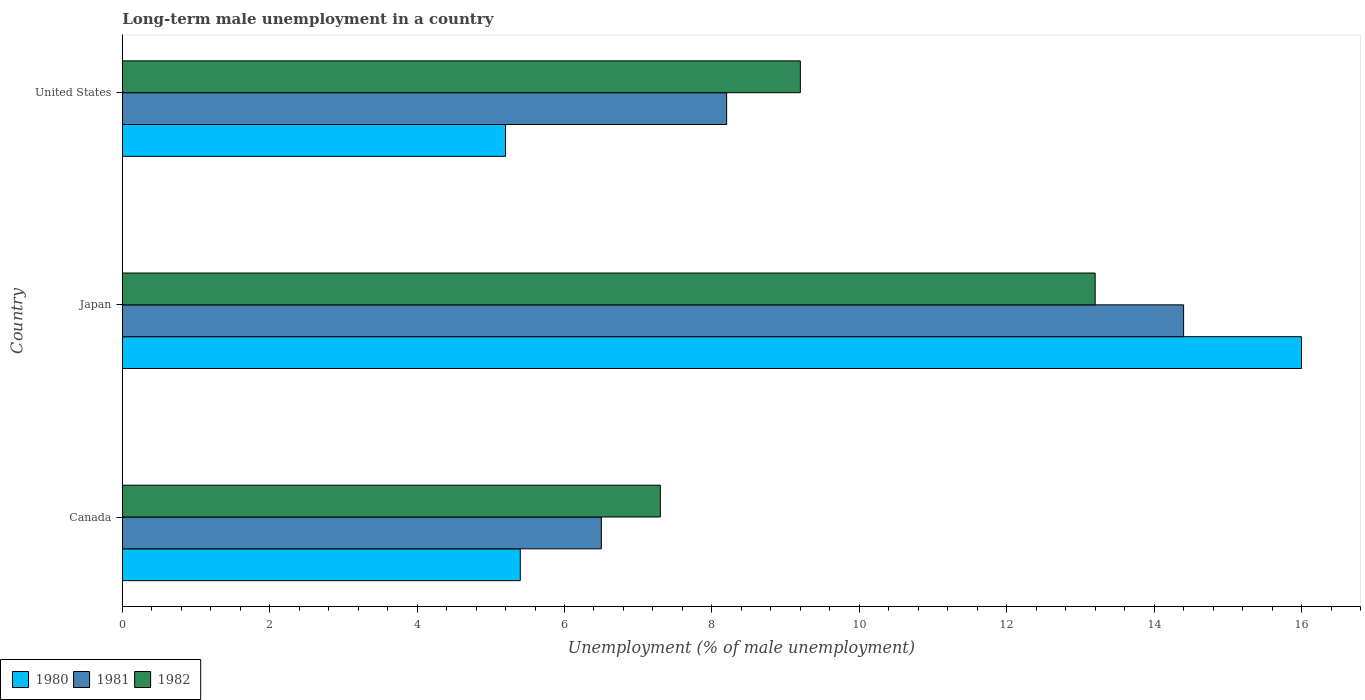How many different coloured bars are there?
Make the answer very short. 3. Are the number of bars per tick equal to the number of legend labels?
Give a very brief answer. Yes. Are the number of bars on each tick of the Y-axis equal?
Give a very brief answer. Yes. How many bars are there on the 1st tick from the top?
Make the answer very short. 3. What is the label of the 3rd group of bars from the top?
Keep it short and to the point. Canada. In how many cases, is the number of bars for a given country not equal to the number of legend labels?
Ensure brevity in your answer.  0. What is the percentage of long-term unemployed male population in 1982 in Canada?
Give a very brief answer. 7.3. Across all countries, what is the maximum percentage of long-term unemployed male population in 1982?
Keep it short and to the point. 13.2. Across all countries, what is the minimum percentage of long-term unemployed male population in 1982?
Offer a very short reply. 7.3. In which country was the percentage of long-term unemployed male population in 1981 maximum?
Make the answer very short. Japan. What is the total percentage of long-term unemployed male population in 1980 in the graph?
Offer a terse response. 26.6. What is the difference between the percentage of long-term unemployed male population in 1980 in Japan and that in United States?
Your answer should be very brief. 10.8. What is the difference between the percentage of long-term unemployed male population in 1981 in Canada and the percentage of long-term unemployed male population in 1980 in United States?
Offer a terse response. 1.3. What is the average percentage of long-term unemployed male population in 1982 per country?
Your answer should be compact. 9.9. What is the difference between the percentage of long-term unemployed male population in 1982 and percentage of long-term unemployed male population in 1980 in Japan?
Keep it short and to the point. -2.8. In how many countries, is the percentage of long-term unemployed male population in 1980 greater than 0.4 %?
Your answer should be compact. 3. What is the ratio of the percentage of long-term unemployed male population in 1982 in Japan to that in United States?
Give a very brief answer. 1.43. Is the percentage of long-term unemployed male population in 1980 in Canada less than that in Japan?
Give a very brief answer. Yes. Is the difference between the percentage of long-term unemployed male population in 1982 in Canada and United States greater than the difference between the percentage of long-term unemployed male population in 1980 in Canada and United States?
Provide a succinct answer. No. What is the difference between the highest and the second highest percentage of long-term unemployed male population in 1982?
Keep it short and to the point. 4. What is the difference between the highest and the lowest percentage of long-term unemployed male population in 1982?
Offer a very short reply. 5.9. In how many countries, is the percentage of long-term unemployed male population in 1981 greater than the average percentage of long-term unemployed male population in 1981 taken over all countries?
Offer a terse response. 1. Is the sum of the percentage of long-term unemployed male population in 1981 in Canada and United States greater than the maximum percentage of long-term unemployed male population in 1980 across all countries?
Give a very brief answer. No. What does the 1st bar from the bottom in United States represents?
Make the answer very short. 1980. How many bars are there?
Offer a very short reply. 9. What is the difference between two consecutive major ticks on the X-axis?
Your answer should be compact. 2. Are the values on the major ticks of X-axis written in scientific E-notation?
Make the answer very short. No. What is the title of the graph?
Provide a succinct answer. Long-term male unemployment in a country. What is the label or title of the X-axis?
Your response must be concise. Unemployment (% of male unemployment). What is the label or title of the Y-axis?
Give a very brief answer. Country. What is the Unemployment (% of male unemployment) in 1980 in Canada?
Your answer should be very brief. 5.4. What is the Unemployment (% of male unemployment) of 1981 in Canada?
Your answer should be compact. 6.5. What is the Unemployment (% of male unemployment) of 1982 in Canada?
Offer a terse response. 7.3. What is the Unemployment (% of male unemployment) of 1980 in Japan?
Your answer should be very brief. 16. What is the Unemployment (% of male unemployment) in 1981 in Japan?
Your response must be concise. 14.4. What is the Unemployment (% of male unemployment) in 1982 in Japan?
Ensure brevity in your answer.  13.2. What is the Unemployment (% of male unemployment) of 1980 in United States?
Keep it short and to the point. 5.2. What is the Unemployment (% of male unemployment) in 1981 in United States?
Your answer should be very brief. 8.2. What is the Unemployment (% of male unemployment) in 1982 in United States?
Offer a very short reply. 9.2. Across all countries, what is the maximum Unemployment (% of male unemployment) in 1980?
Give a very brief answer. 16. Across all countries, what is the maximum Unemployment (% of male unemployment) in 1981?
Give a very brief answer. 14.4. Across all countries, what is the maximum Unemployment (% of male unemployment) of 1982?
Offer a very short reply. 13.2. Across all countries, what is the minimum Unemployment (% of male unemployment) in 1980?
Make the answer very short. 5.2. Across all countries, what is the minimum Unemployment (% of male unemployment) in 1981?
Give a very brief answer. 6.5. Across all countries, what is the minimum Unemployment (% of male unemployment) in 1982?
Give a very brief answer. 7.3. What is the total Unemployment (% of male unemployment) in 1980 in the graph?
Make the answer very short. 26.6. What is the total Unemployment (% of male unemployment) in 1981 in the graph?
Offer a very short reply. 29.1. What is the total Unemployment (% of male unemployment) of 1982 in the graph?
Offer a terse response. 29.7. What is the difference between the Unemployment (% of male unemployment) of 1980 in Canada and that in Japan?
Your response must be concise. -10.6. What is the difference between the Unemployment (% of male unemployment) in 1982 in Canada and that in Japan?
Your response must be concise. -5.9. What is the difference between the Unemployment (% of male unemployment) of 1980 in Japan and that in United States?
Keep it short and to the point. 10.8. What is the difference between the Unemployment (% of male unemployment) of 1981 in Japan and that in United States?
Keep it short and to the point. 6.2. What is the difference between the Unemployment (% of male unemployment) of 1980 in Canada and the Unemployment (% of male unemployment) of 1982 in Japan?
Offer a very short reply. -7.8. What is the difference between the Unemployment (% of male unemployment) in 1981 in Canada and the Unemployment (% of male unemployment) in 1982 in Japan?
Offer a terse response. -6.7. What is the difference between the Unemployment (% of male unemployment) in 1980 in Japan and the Unemployment (% of male unemployment) in 1982 in United States?
Ensure brevity in your answer.  6.8. What is the difference between the Unemployment (% of male unemployment) of 1981 in Japan and the Unemployment (% of male unemployment) of 1982 in United States?
Offer a very short reply. 5.2. What is the average Unemployment (% of male unemployment) of 1980 per country?
Make the answer very short. 8.87. What is the difference between the Unemployment (% of male unemployment) of 1981 and Unemployment (% of male unemployment) of 1982 in Japan?
Provide a succinct answer. 1.2. What is the difference between the Unemployment (% of male unemployment) of 1980 and Unemployment (% of male unemployment) of 1982 in United States?
Make the answer very short. -4. What is the ratio of the Unemployment (% of male unemployment) of 1980 in Canada to that in Japan?
Keep it short and to the point. 0.34. What is the ratio of the Unemployment (% of male unemployment) of 1981 in Canada to that in Japan?
Provide a succinct answer. 0.45. What is the ratio of the Unemployment (% of male unemployment) in 1982 in Canada to that in Japan?
Your answer should be very brief. 0.55. What is the ratio of the Unemployment (% of male unemployment) of 1980 in Canada to that in United States?
Provide a short and direct response. 1.04. What is the ratio of the Unemployment (% of male unemployment) of 1981 in Canada to that in United States?
Provide a short and direct response. 0.79. What is the ratio of the Unemployment (% of male unemployment) of 1982 in Canada to that in United States?
Provide a succinct answer. 0.79. What is the ratio of the Unemployment (% of male unemployment) of 1980 in Japan to that in United States?
Provide a succinct answer. 3.08. What is the ratio of the Unemployment (% of male unemployment) of 1981 in Japan to that in United States?
Your answer should be very brief. 1.76. What is the ratio of the Unemployment (% of male unemployment) in 1982 in Japan to that in United States?
Provide a succinct answer. 1.43. What is the difference between the highest and the lowest Unemployment (% of male unemployment) in 1981?
Make the answer very short. 7.9. 